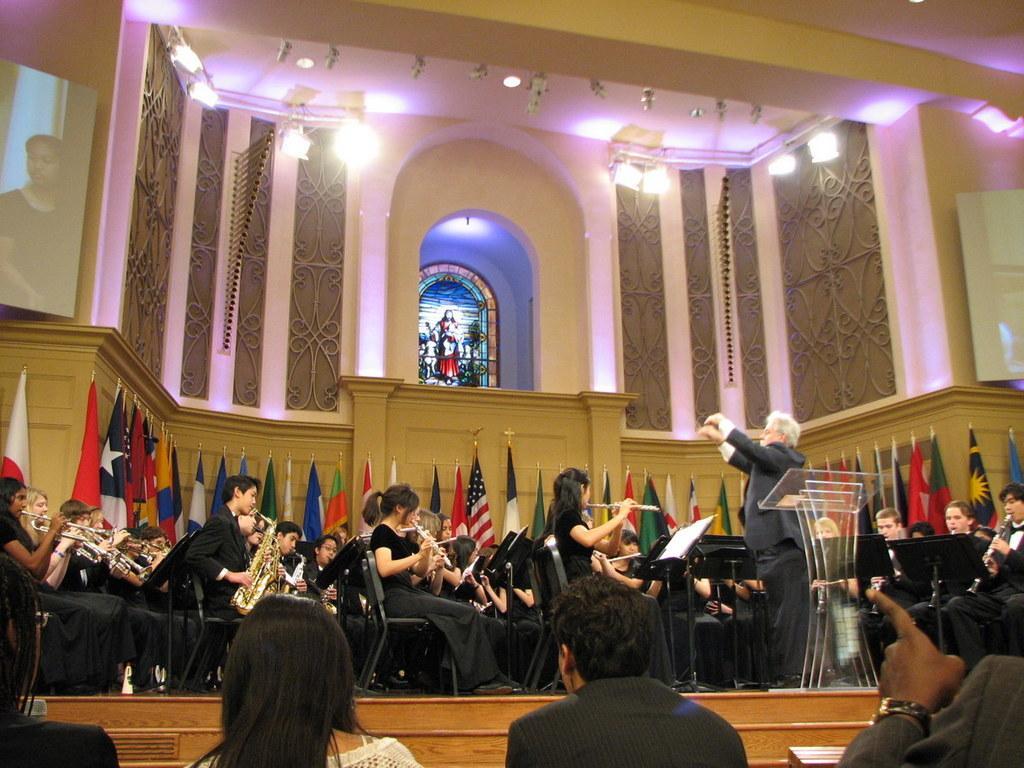Can you describe this image briefly? In this picture we can see big hall. In front we can see a group of orchestra. Behind there are some colorful flags of the country. Above there is a statue in the center of the arch. On the top there is a ceiling with track lights. In the front bottom side there are some person sitting and watching the orchestra. 